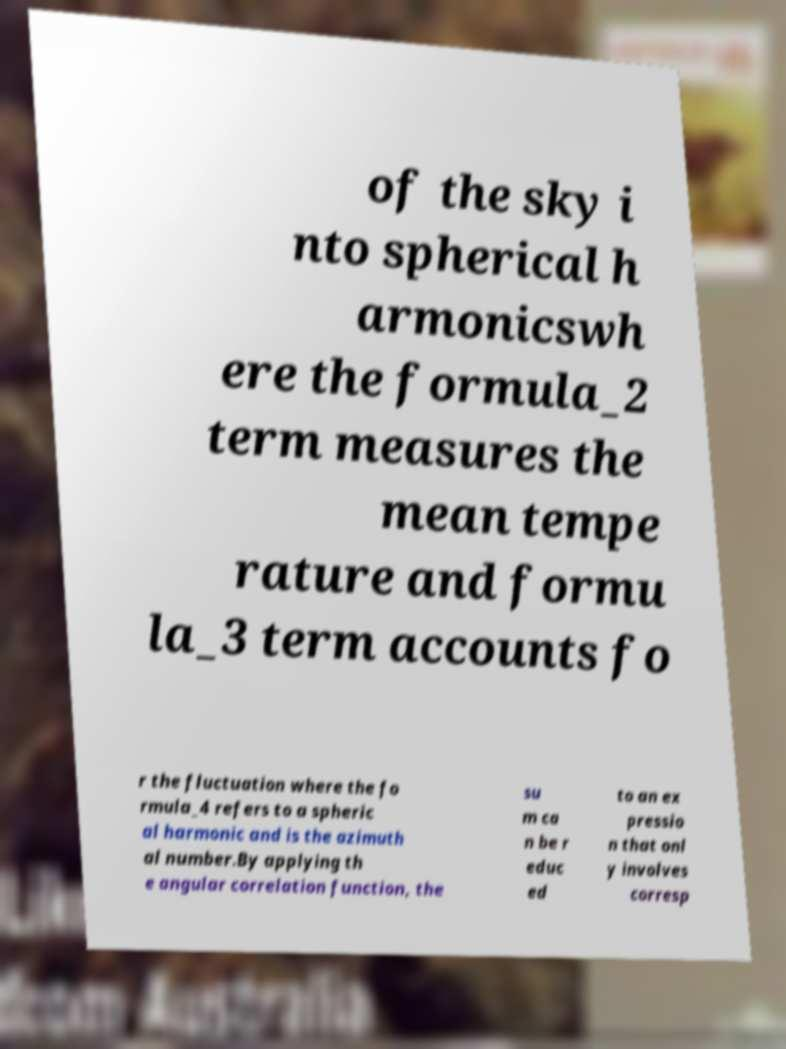What messages or text are displayed in this image? I need them in a readable, typed format. of the sky i nto spherical h armonicswh ere the formula_2 term measures the mean tempe rature and formu la_3 term accounts fo r the fluctuation where the fo rmula_4 refers to a spheric al harmonic and is the azimuth al number.By applying th e angular correlation function, the su m ca n be r educ ed to an ex pressio n that onl y involves corresp 